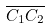<formula> <loc_0><loc_0><loc_500><loc_500>\overline { C _ { 1 } C _ { 2 } }</formula> 